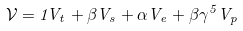Convert formula to latex. <formula><loc_0><loc_0><loc_500><loc_500>\mathcal { V } = 1 V _ { t } + \beta V _ { s } + \alpha V _ { e } + \beta \gamma ^ { 5 } V _ { p }</formula> 